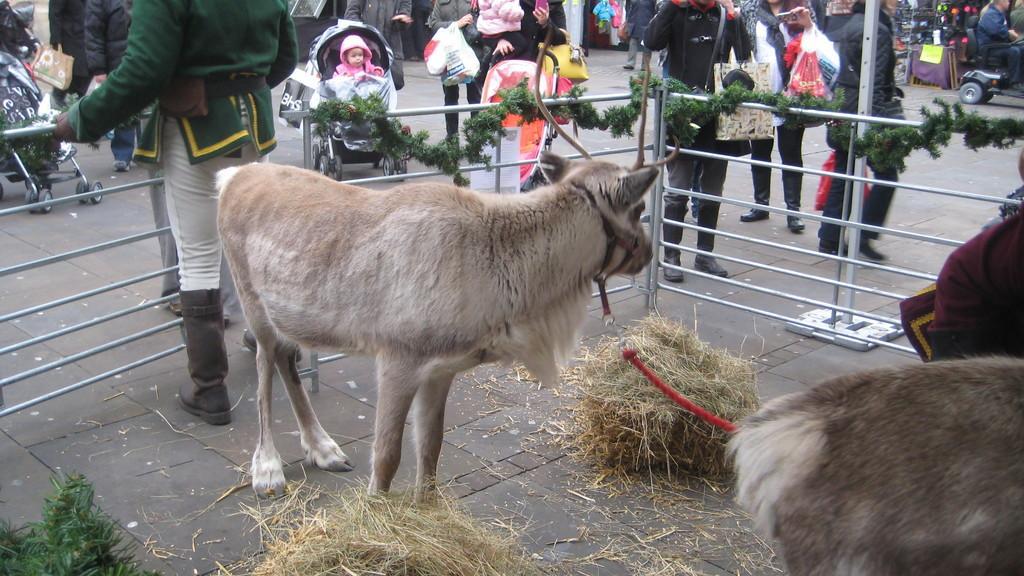How would you summarize this image in a sentence or two? In this picture I can see animals, dried grass bundles, iron grills, garlands, and in the background there are group of people standing and there are some other items. 